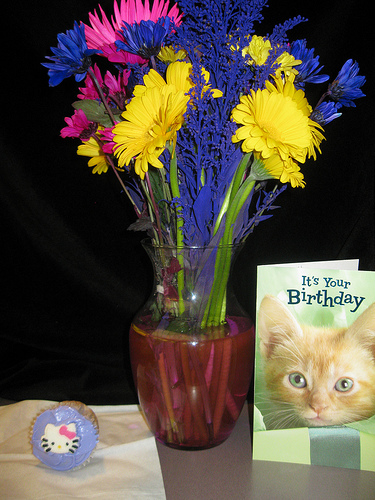<image>
Is the vase to the left of the card? Yes. From this viewpoint, the vase is positioned to the left side relative to the card. 